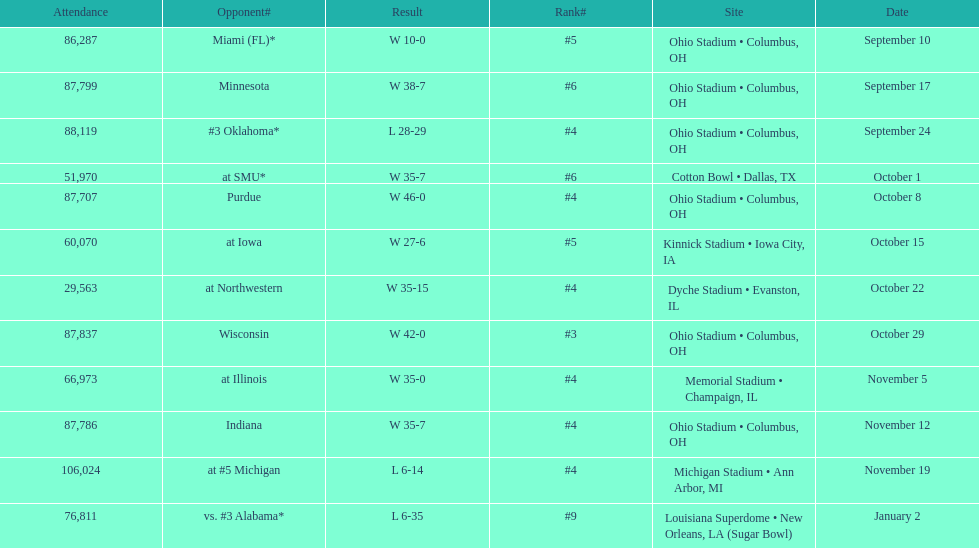What is the difference between the number of wins and the number of losses? 6. 